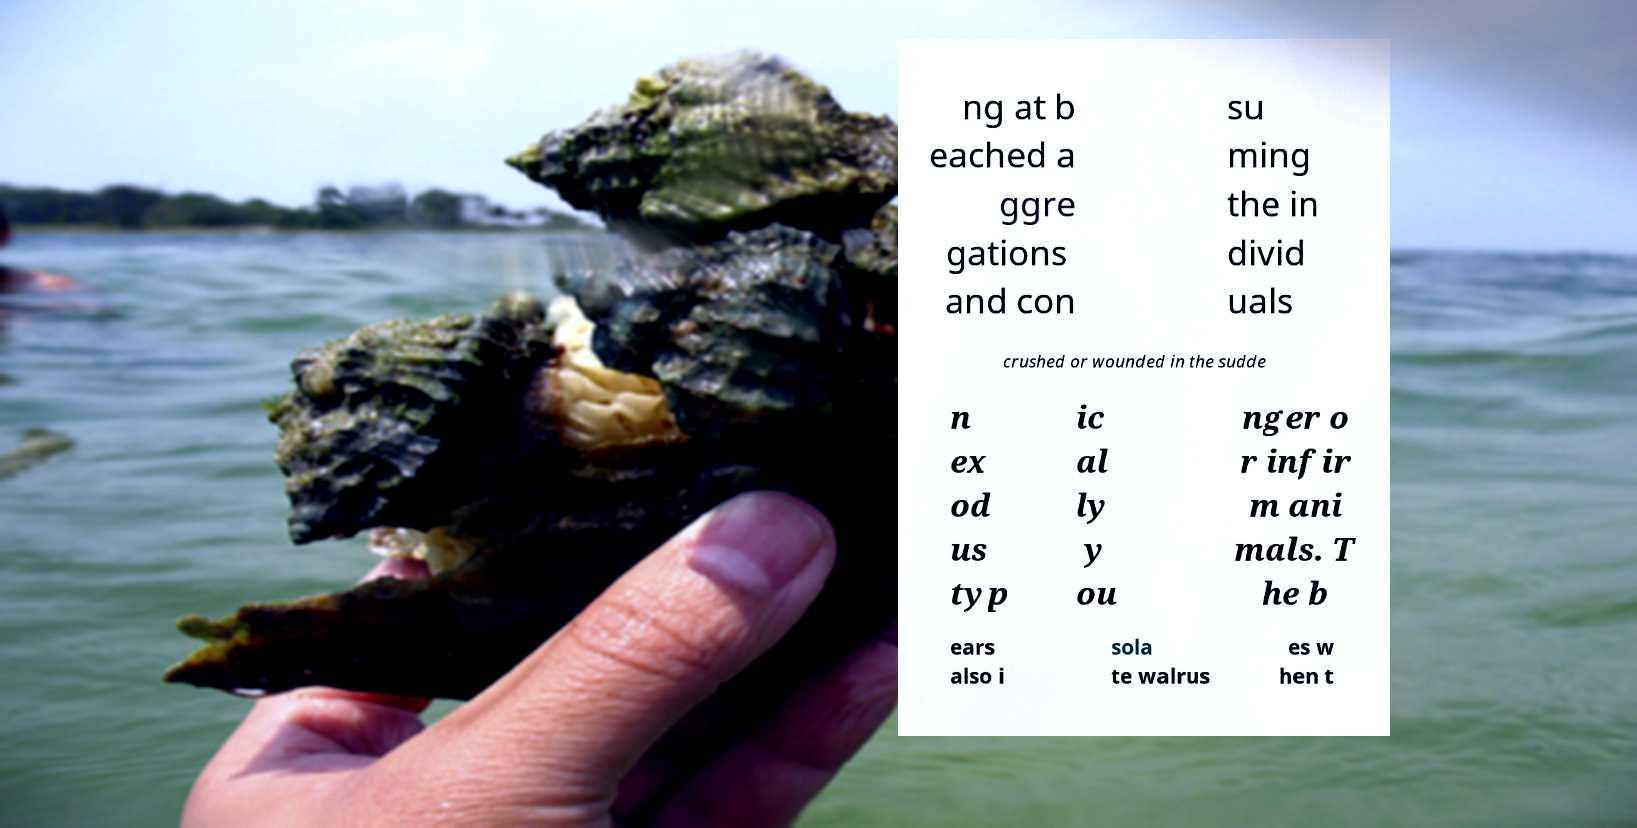Please identify and transcribe the text found in this image. ng at b eached a ggre gations and con su ming the in divid uals crushed or wounded in the sudde n ex od us typ ic al ly y ou nger o r infir m ani mals. T he b ears also i sola te walrus es w hen t 